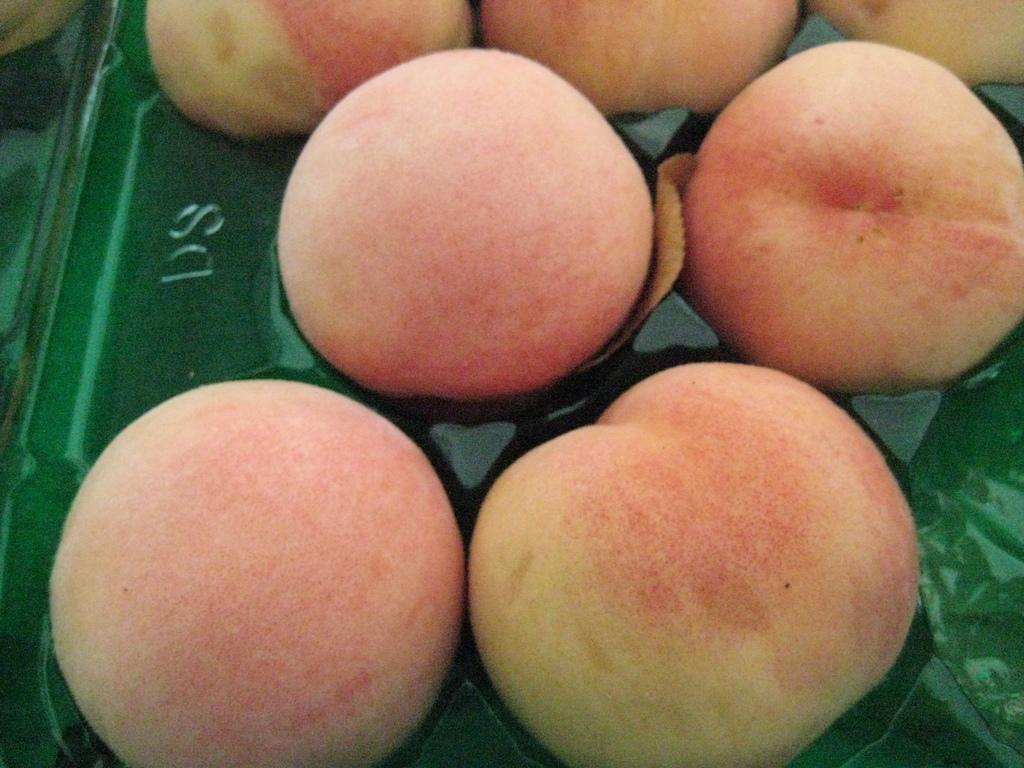Please provide a concise description of this image. In the image we can see some fruits. 